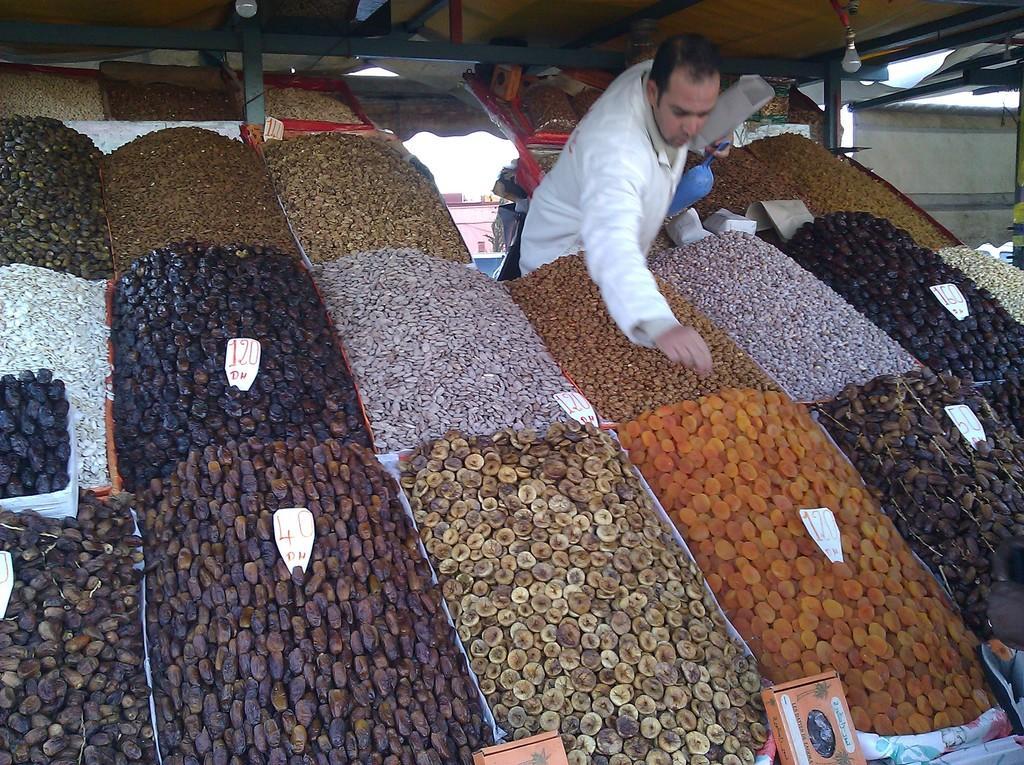Describe this image in one or two sentences. Here there are different food items, here a man is standing, this is light. 